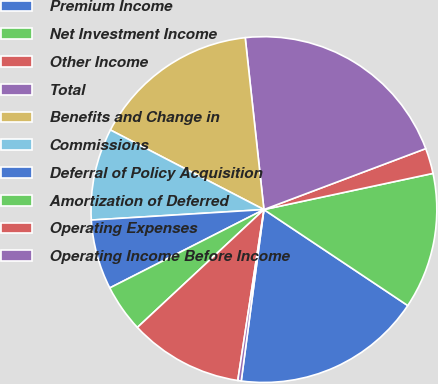Convert chart. <chart><loc_0><loc_0><loc_500><loc_500><pie_chart><fcel>Premium Income<fcel>Net Investment Income<fcel>Other Income<fcel>Total<fcel>Benefits and Change in<fcel>Commissions<fcel>Deferral of Policy Acquisition<fcel>Amortization of Deferred<fcel>Operating Expenses<fcel>Operating Income Before Income<nl><fcel>17.73%<fcel>12.72%<fcel>2.38%<fcel>20.99%<fcel>15.66%<fcel>8.58%<fcel>6.52%<fcel>4.45%<fcel>10.65%<fcel>0.32%<nl></chart> 